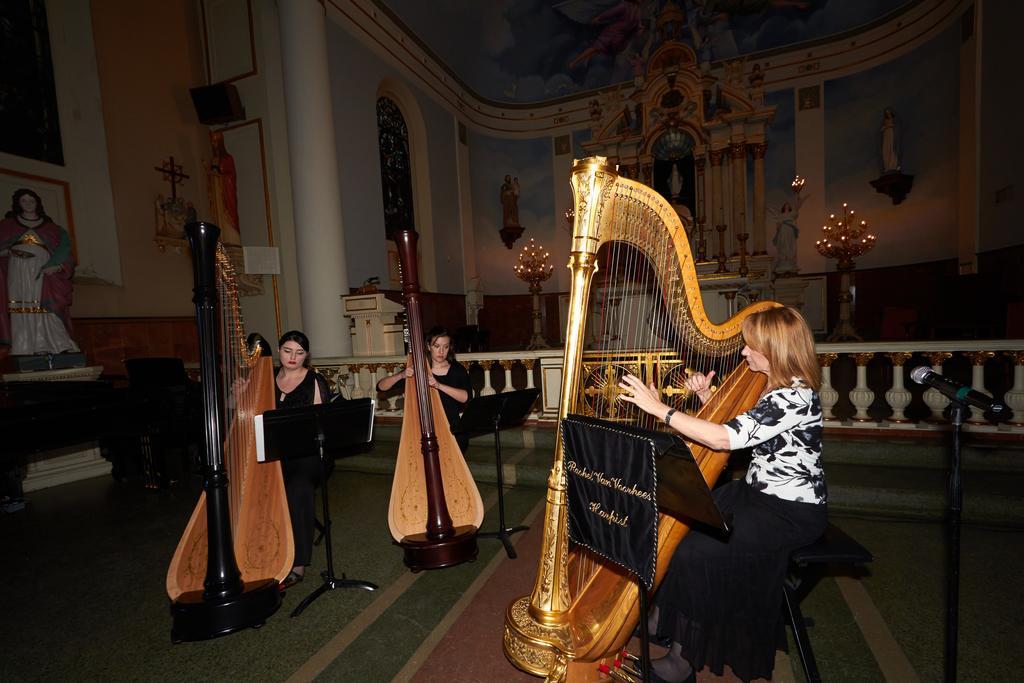Describe this image in one or two sentences. In this image we can see three people, playing musical instruments, in front of them are stands, with books on it, there is a mic, sculptures, cross symbols, pillars, speaker, candles, also we can see the wall. 